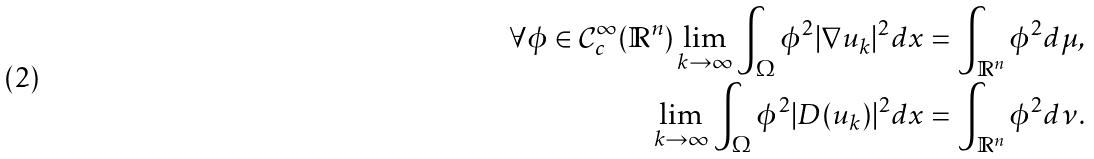<formula> <loc_0><loc_0><loc_500><loc_500>\forall \phi \in \mathcal { C } _ { c } ^ { \infty } ( \mathbb { R } ^ { n } ) \lim _ { k \to \infty } \int _ { \Omega } \phi ^ { 2 } | \nabla u _ { k } | ^ { 2 } d x & = \int _ { \mathbb { R } ^ { n } } \phi ^ { 2 } d \mu , \\ \lim _ { k \to \infty } \int _ { \Omega } \phi ^ { 2 } | D ( u _ { k } ) | ^ { 2 } d x & = \int _ { \mathbb { R } ^ { n } } \phi ^ { 2 } d \nu .</formula> 